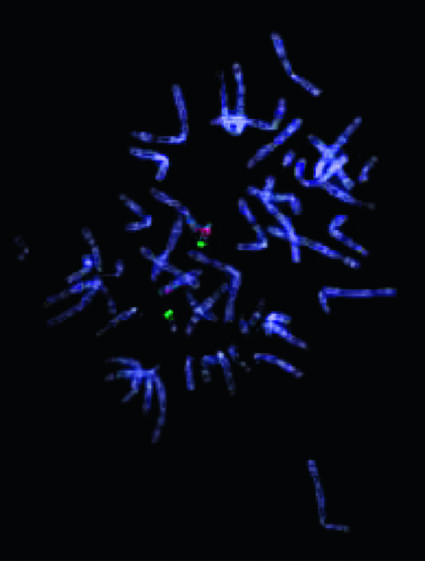does sci transl give rise to the 22q11 .2 deletion syndrome digeorge syndrome?
Answer the question using a single word or phrase. No 